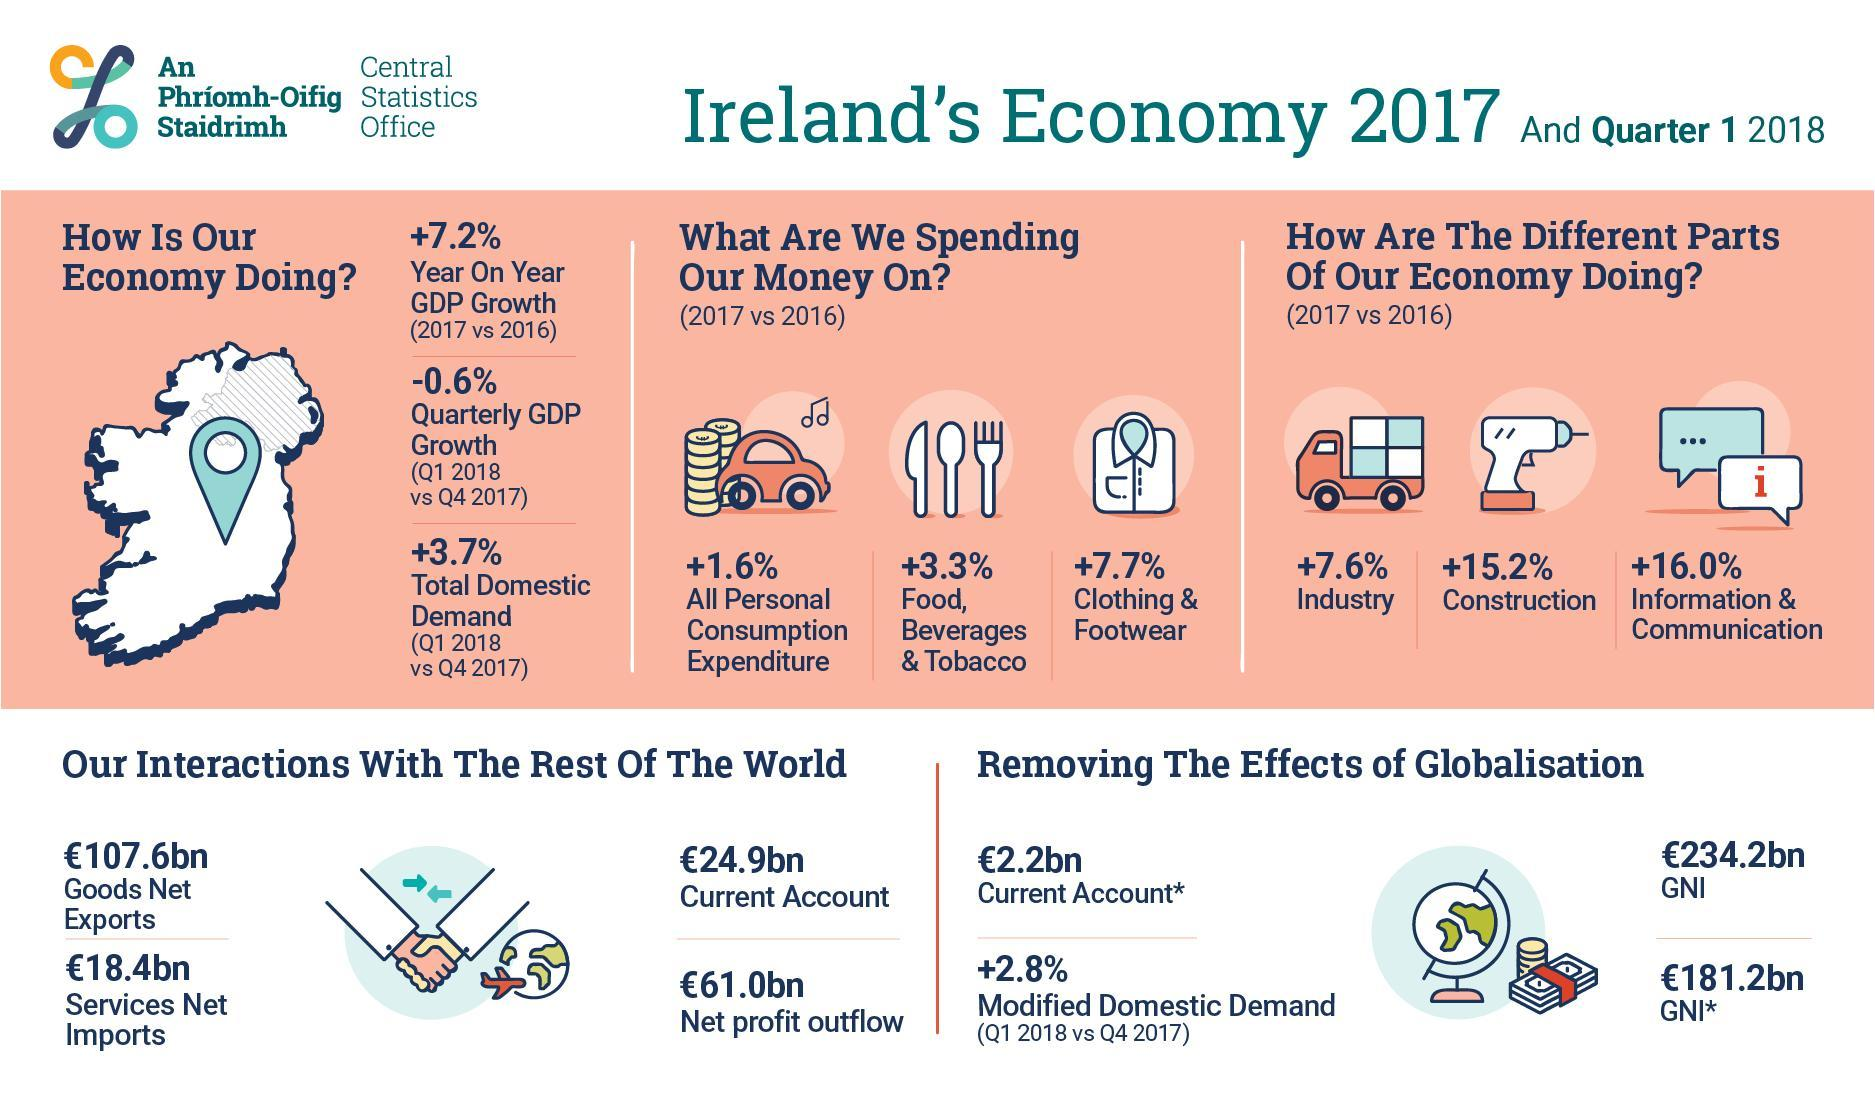What is the % increase in GDP 2017 vs 2016?
Answer the question with a short phrase. 7.2% What is the % increase in spending on food, beverages & tobacco from 2016? 3.3% In which sector has the expenditure increased by 15.2%? Construction What spending has increased by 1.6% from 2016-2017? All personal consumption expenditure In which sector has the expenditure increased by 16.0%? Information & communication By how much percent has the spending on clothes and footwear increased from 2016? 7.7% Compared to which year has the spending on industry sector increased by 7.6%? 2016 